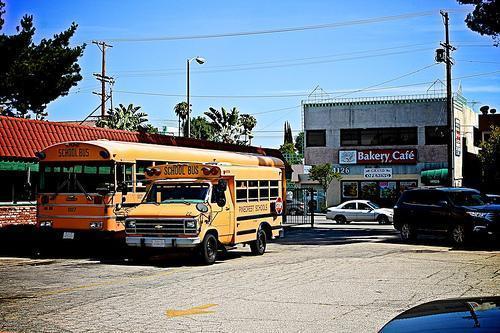How many buses do you see?
Give a very brief answer. 2. 